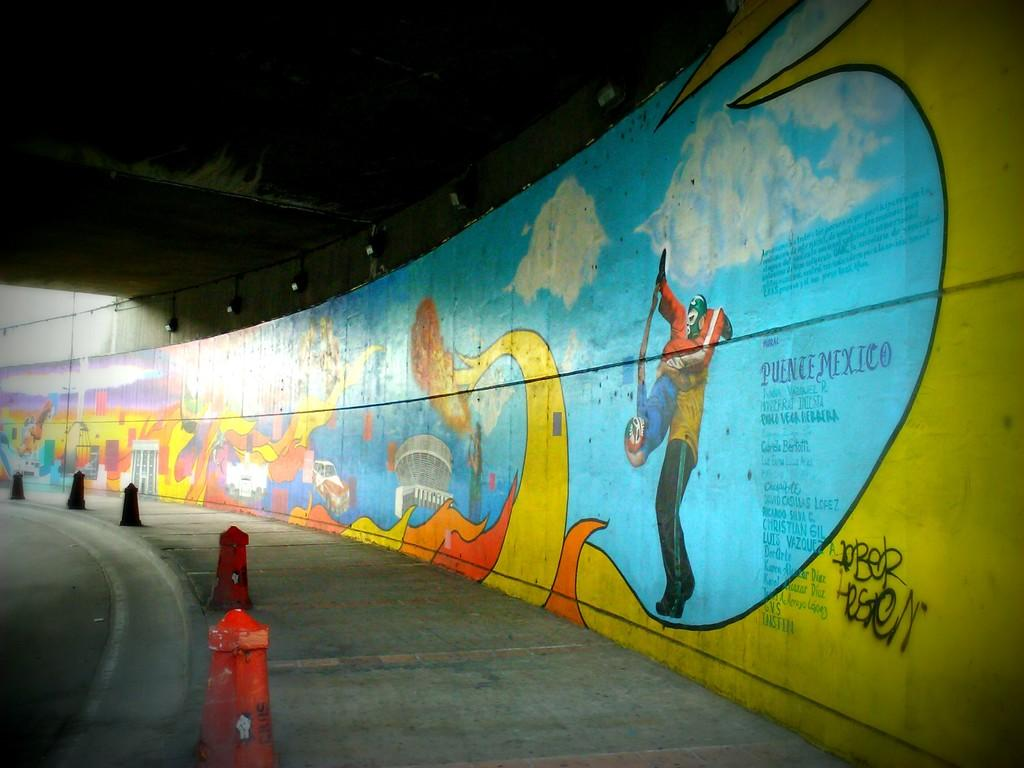What type of artwork can be seen on the wall in the image? There are paintings on the wall in the image. What type of lighting is present in the image? There are electric lights in the image. What type of road feature is visible in the image? There are barrier poles on the road in the image. What type of fruit is hanging from the barrier poles in the image? There is no fruit present in the image; it features paintings on the wall, electric lights, and barrier poles on the road. What type of cushion is placed on the barrier poles in the image? There is no cushion present on the barrier poles in the image. 